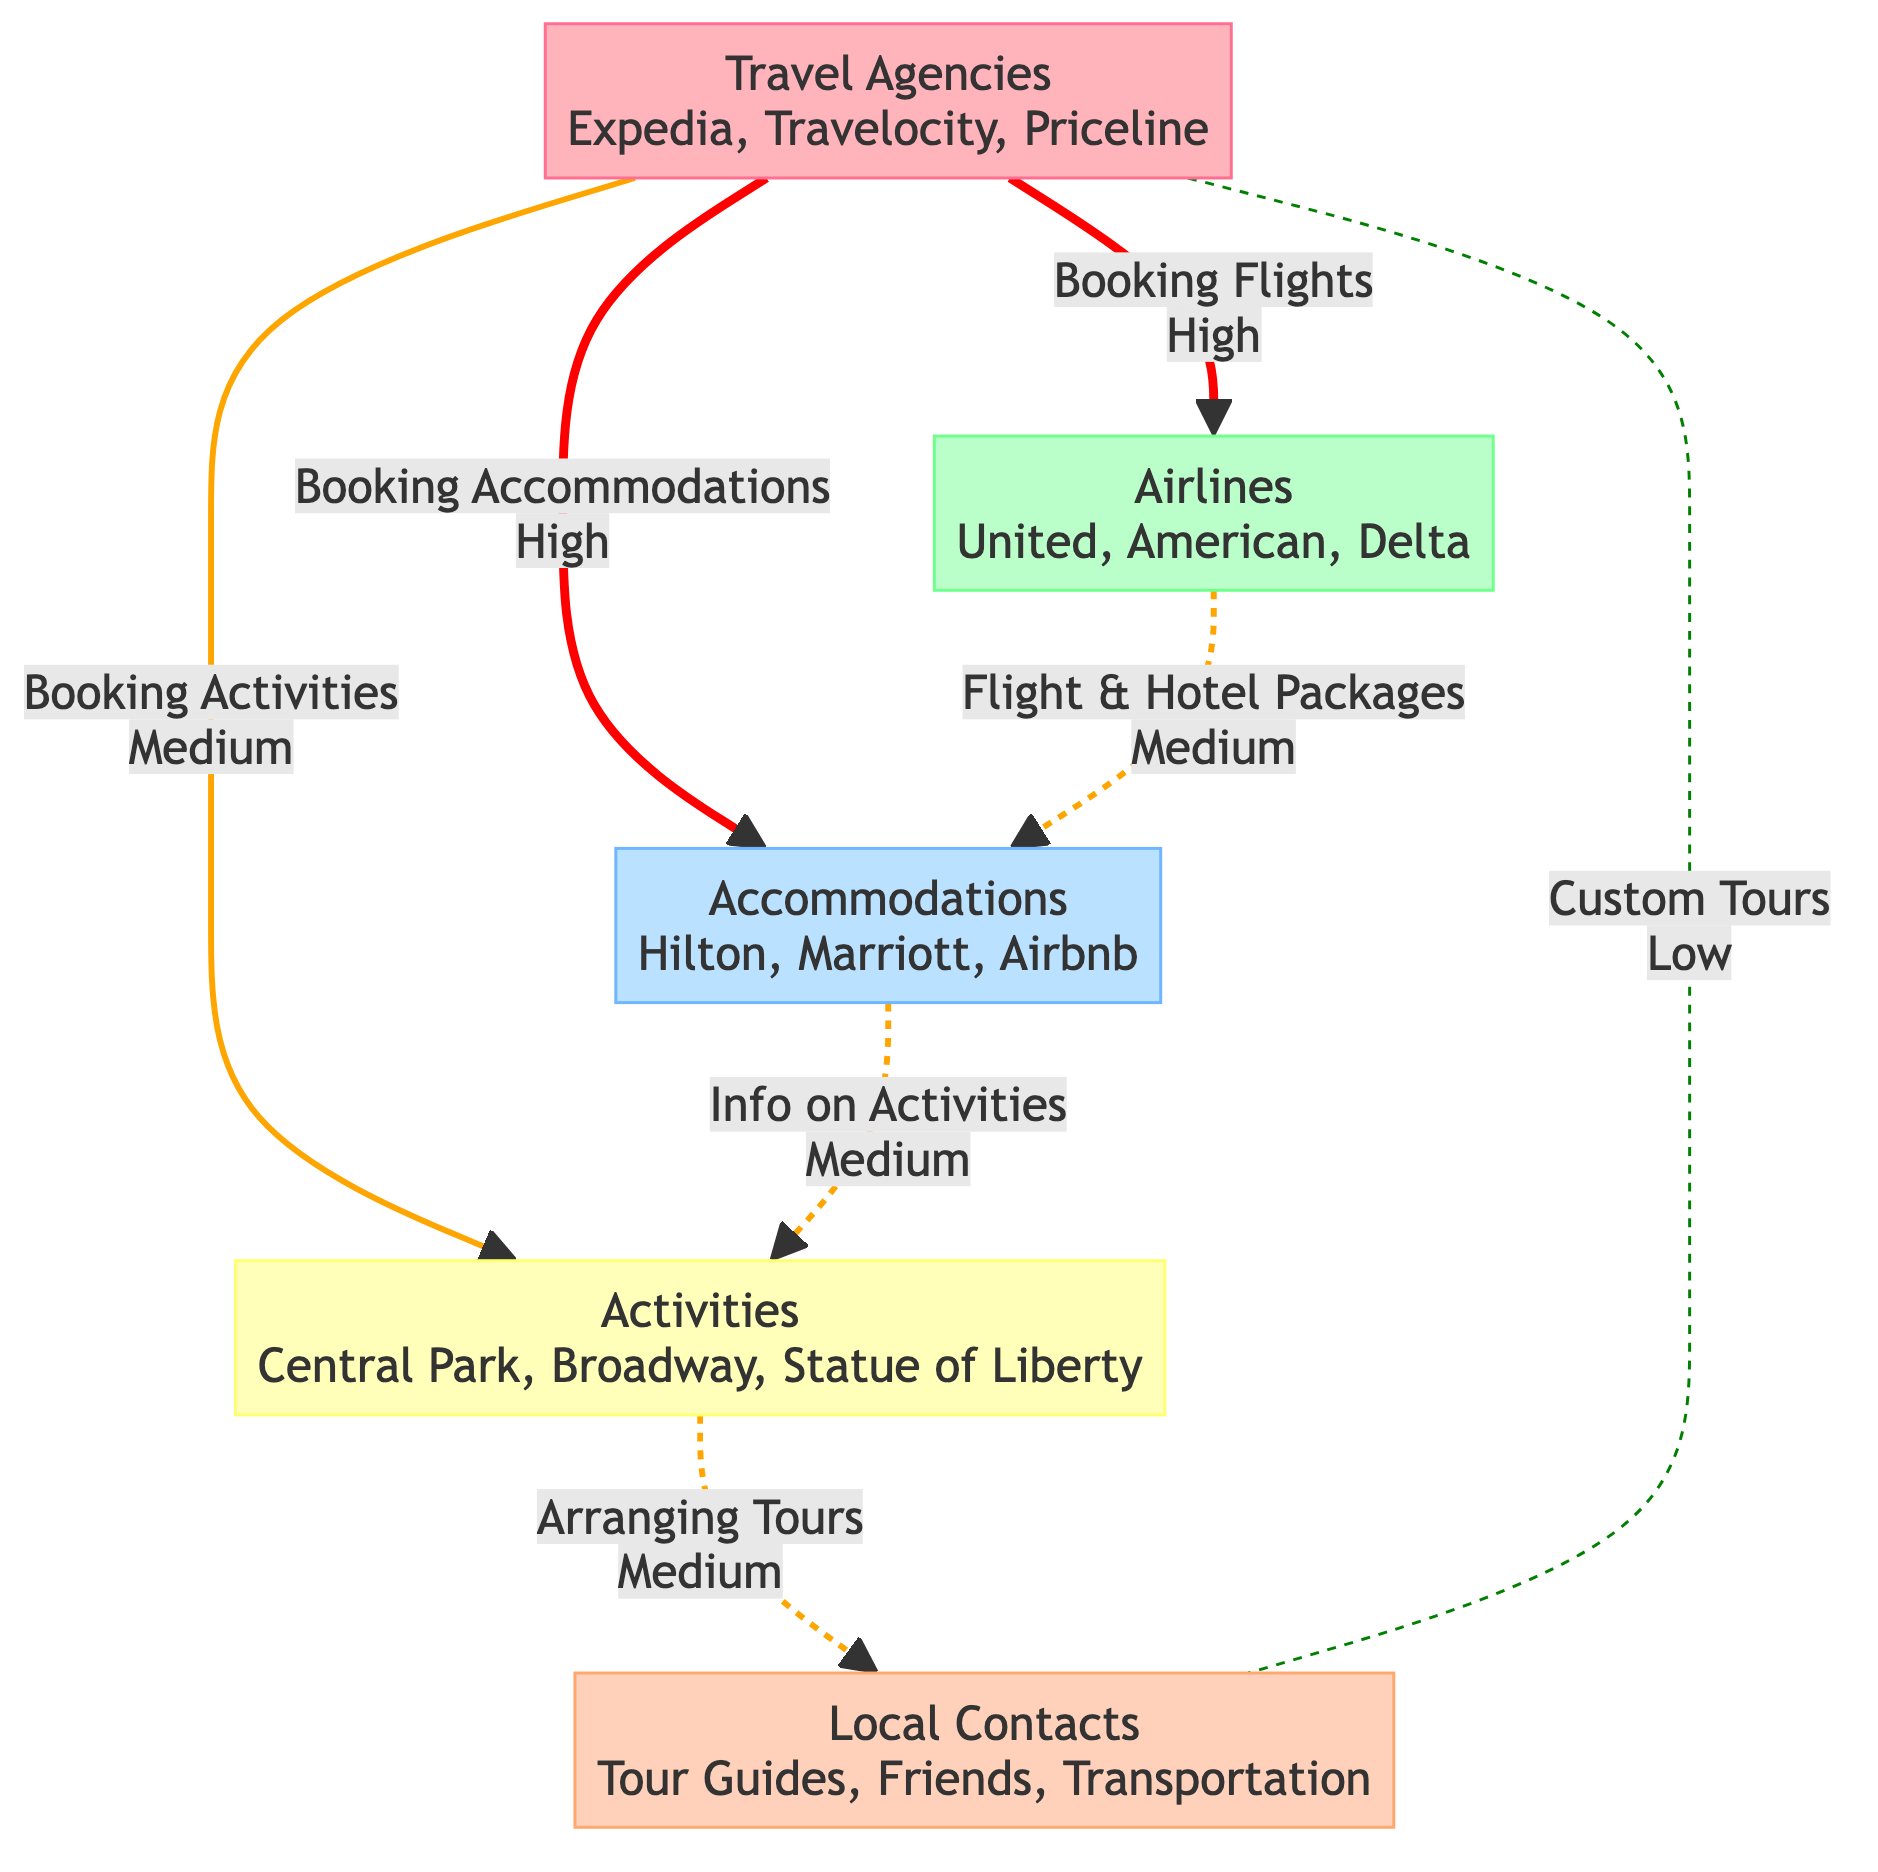What are the three travel agencies listed in the diagram? The diagram displays three travel agencies as nodes. Specifically, under the "Travel Agencies" node, the entities mentioned are Expedia, Travelocity, and Priceline.
Answer: Expedia, Travelocity, Priceline How many nodes are there in total in the diagram? The diagram contains five distinct nodes representing different categories: Travel Agencies, Airlines, Accommodations, Activities, and Local Contacts. Therefore, the total number of nodes is five.
Answer: 5 What type of interaction occurs between Travel Agencies and Airlines? The diagram indicates a direct link from "Travel Agencies" to "Airlines" with the interaction labeled "Booking Flights." This is a high importance interaction.
Answer: Booking Flights Which edge represents the lowest importance interaction? In the diagram, the link from "Travel Agencies" to "Local Contacts," related to "Coordinating with Local Contacts for Custom Tours," is indicated with low importance, making it the lowest among the presented interactions.
Answer: Custom Tours How many edges are there in total in the diagram? By reviewing the interactions and connections between the nodes, there are a total of seven edges present in the diagram that depict various relationships among the different entities.
Answer: 7 Which accommodations are connected to activities in the diagram? The connection between the "Accommodations" node and the "Activities" node shows the interaction labeled "Providing Information on Local Activities." Therefore, while there are no specific accommodations listed there, the node represents Hilton Hotels, Marriott, and Airbnb, all linked through that connection to activities.
Answer: Hilton Hotels, Marriott, Airbnb What kind of activities are included in the diagram? The "Activities" node lists specific activities available for booking, which are Central Park Tour, Broadway Show Tickets, and Statue of Liberty Cruise, representing the different options travelers can choose from while visiting the destination.
Answer: Central Park Tour, Broadway Show Tickets, Statue of Liberty Cruise Which node has the highest number of direct connections? The "Travel Agencies" node has the highest number of direct connections, with three edges leading to Airlines, Accommodations, and Local Contacts, indicating its central role in the vacation planning process.
Answer: Travel Agencies 